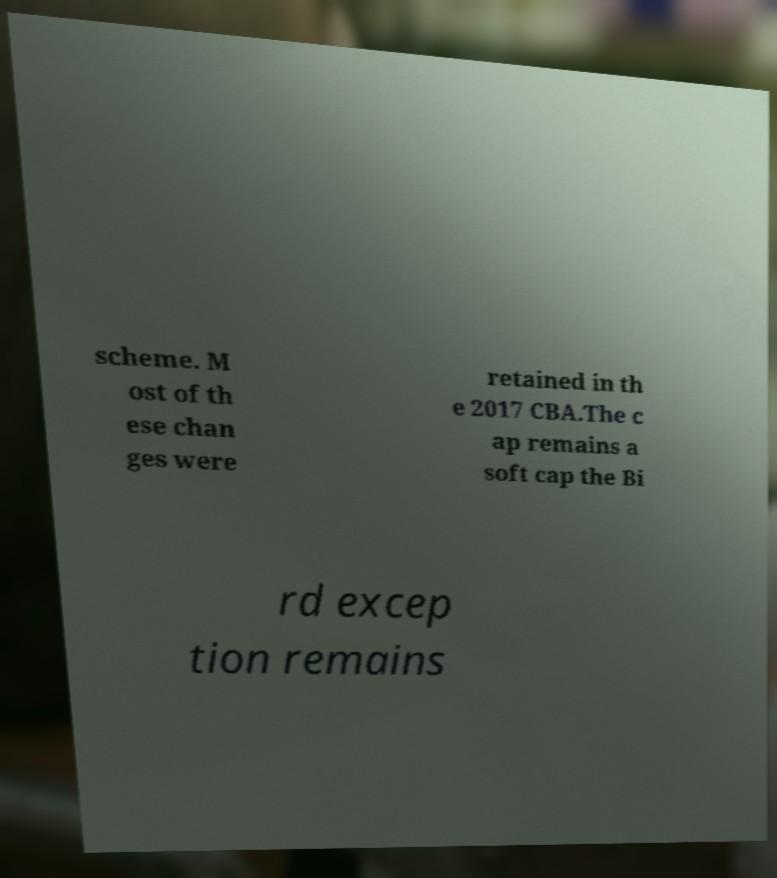Could you assist in decoding the text presented in this image and type it out clearly? scheme. M ost of th ese chan ges were retained in th e 2017 CBA.The c ap remains a soft cap the Bi rd excep tion remains 